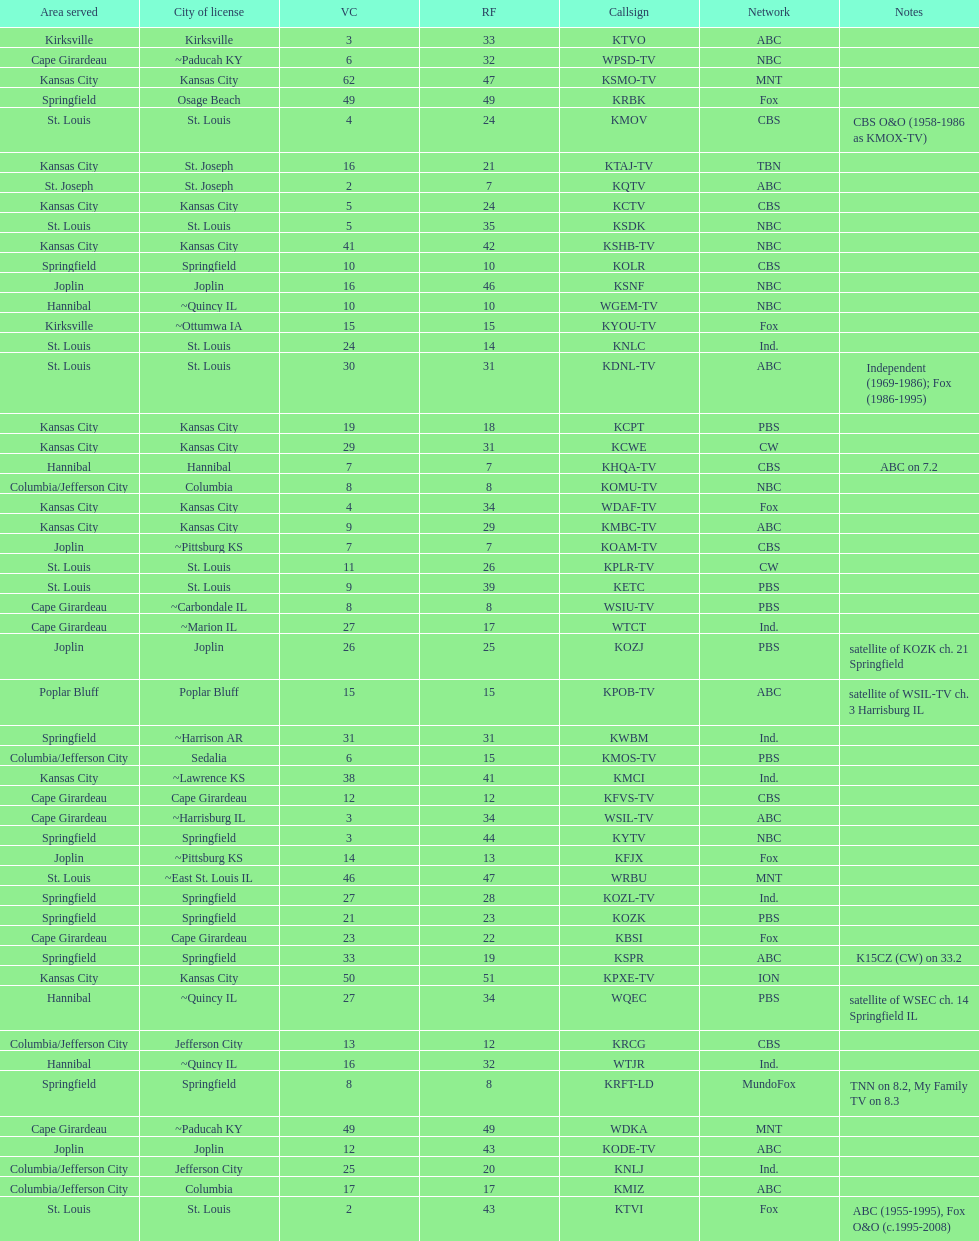What is the total number of stations under the cbs network? 7. 